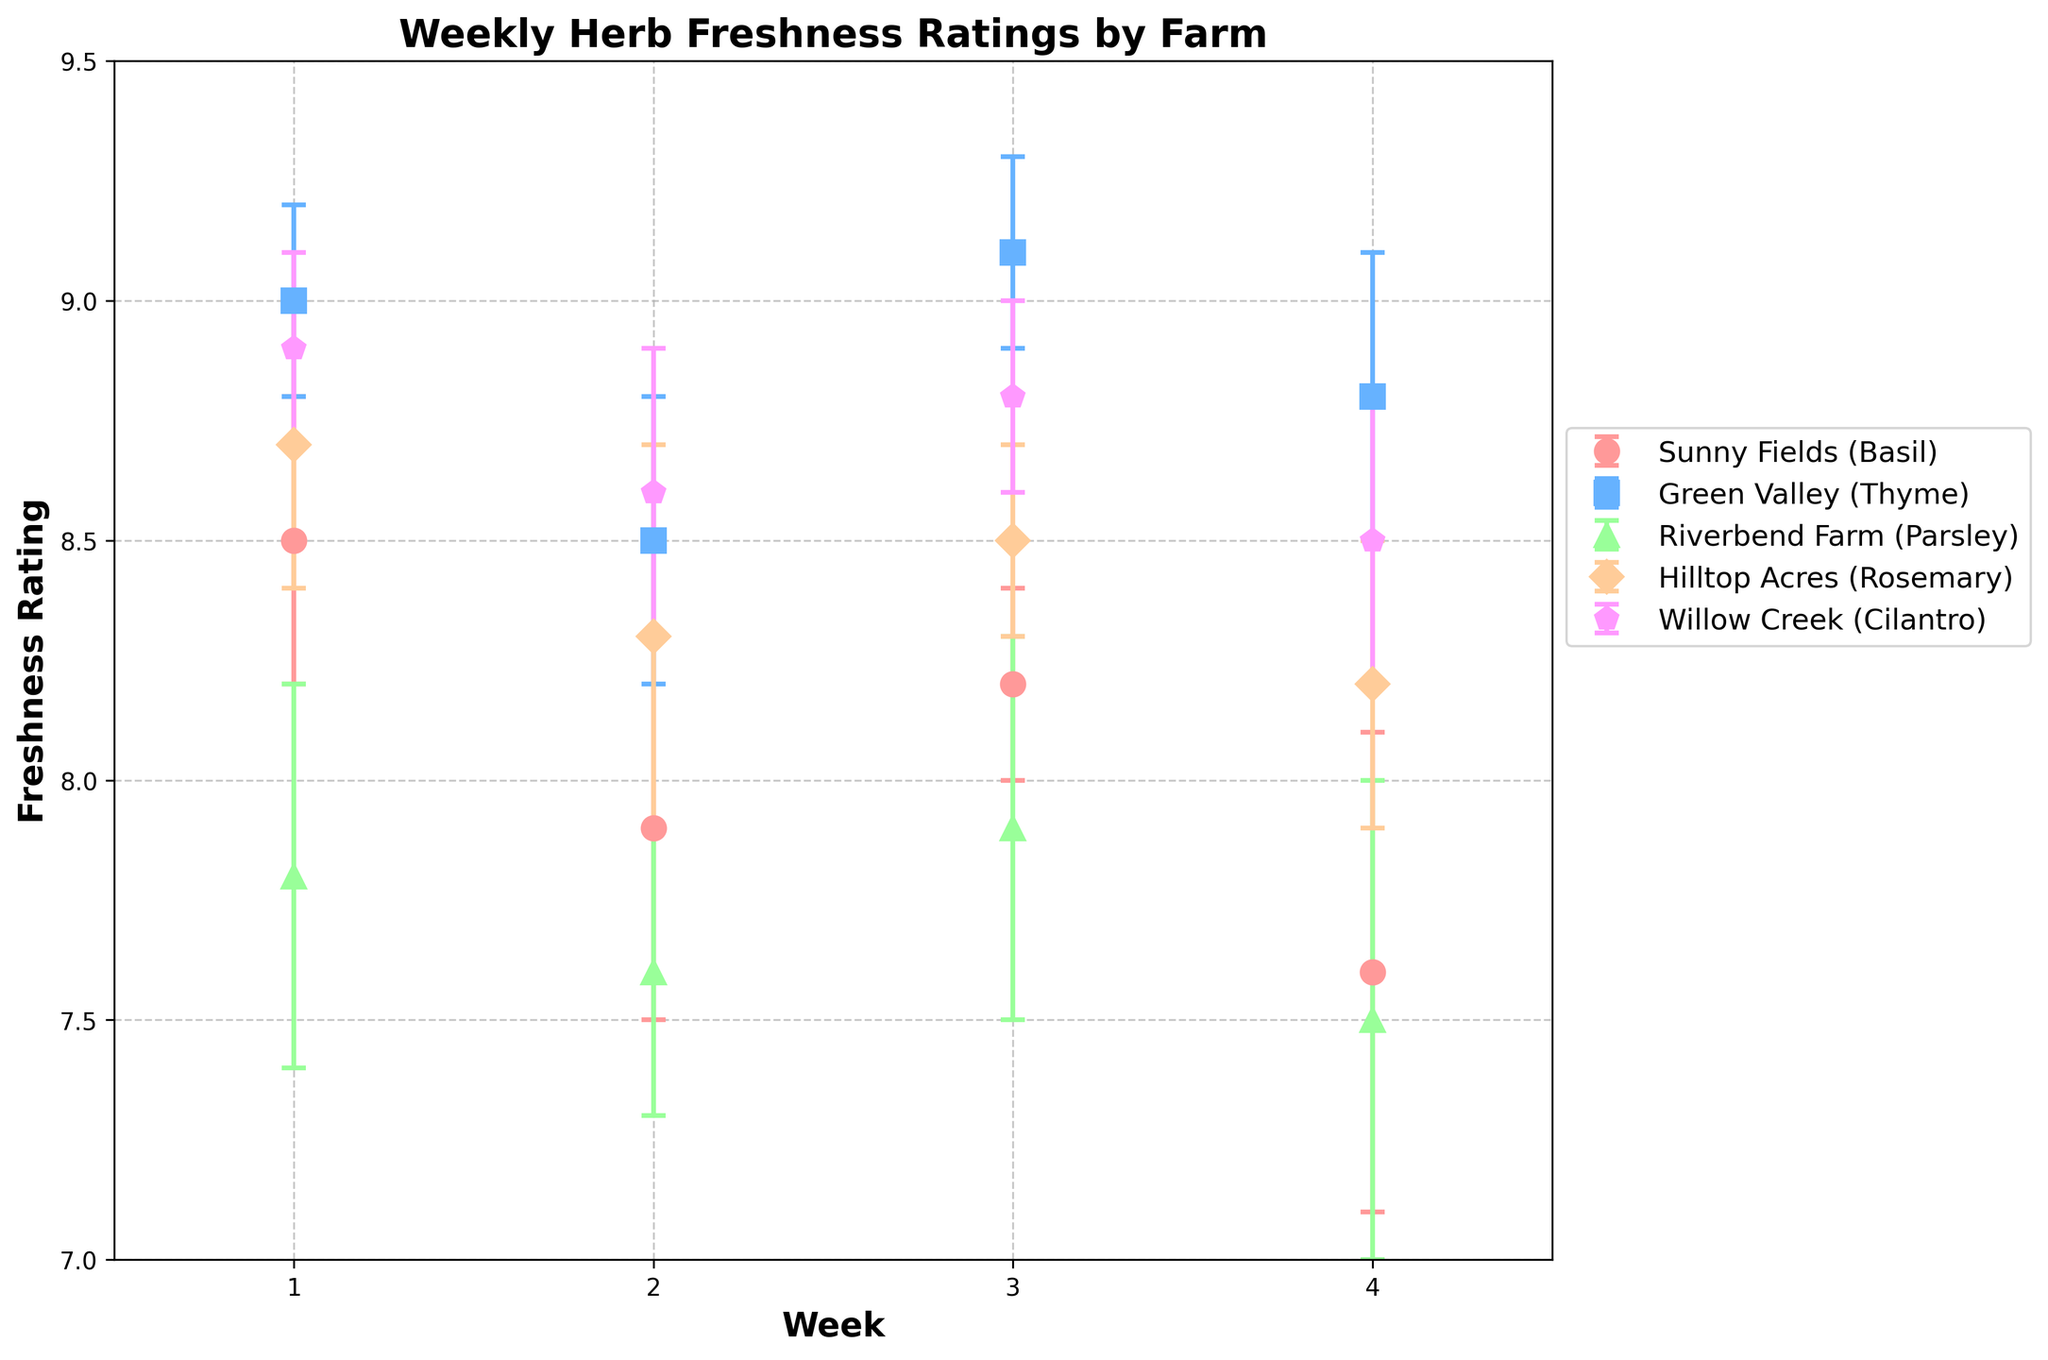What is the title of the plot? The title of the plot is normally located at the top of the figure. In this case, it reads "Weekly Herb Freshness Ratings by Farm".
Answer: Weekly Herb Freshness Ratings by Farm Which farm has the highest freshness rating in Week 1? To determine the highest freshness rating in Week 1, look at the dot positions for Week 1 across all farms. Green Valley has the highest dot at a freshness rating of 9.0.
Answer: Green Valley How does the freshness rating for Sunny Fields change from Week 1 to Week 4? To answer this, observe the dots for Sunny Fields from Week 1 to Week 4. In Week 1, Sunny Fields has a rating of 8.5 which decreases to 7.6 by Week 4. Thus, Sunny Fields' rating decreases from 8.5 to 7.6.
Answer: Decreases from 8.5 to 7.6 What is the range of freshness ratings for Willow Creek over the four weeks? The range is the difference between the highest and lowest ratings. For Willow Creek, the highest rating is 8.9 in Week 1 and the lowest is 8.5 in Week 4. Therefore, the range is 8.9 - 8.5 = 0.4.
Answer: 0.4 Which farm has the most stable freshness rating for its herb? Stability can be evaluated by looking at the range and error bars. Green Valley has a minimal range in freshness ratings (9.0 to 8.5) and relatively small error bars. Thus, Green Valley appears to be the most stable.
Answer: Green Valley Compare the freshness rating trend of Parsley from Riverbend Farm and Rosemary from Hilltop Acres. To compare trends, observe the direction of the dots over weeks. Both have a generally decreasing trend. Riverbend Farm's Parsley goes from 7.8 to 7.5, and Hilltop Acres' Rosemary goes from 8.7 to 8.2 showing both are decreasing but on different scales.
Answer: Both show decreasing trends What is the average freshness rating for Cilantro from Willow Creek over the reported weeks? The average is calculated by summing the ratings and dividing by the count. Sum of Cilantro ratings = 8.9 + 8.6 + 8.8 + 8.5 = 34.8. Average = 34.8 / 4 = 8.7.
Answer: 8.7 Which week shows the greatest variability in freshness ratings across all farms? Greatest variability can be seen where there is the largest spread of dots and error bars. Week 1 shows a range from 7.8 (Riverbend Farm) to 9.0 (Green Valley), indicating the greatest variability.
Answer: Week 1 For which farm is the measurement error the largest in any given week? The error bars or caps with the largest extension indicate the largest measurement error. Sunny Fields in Week 4 has the largest error bar, at 0.5.
Answer: Sunny Fields 